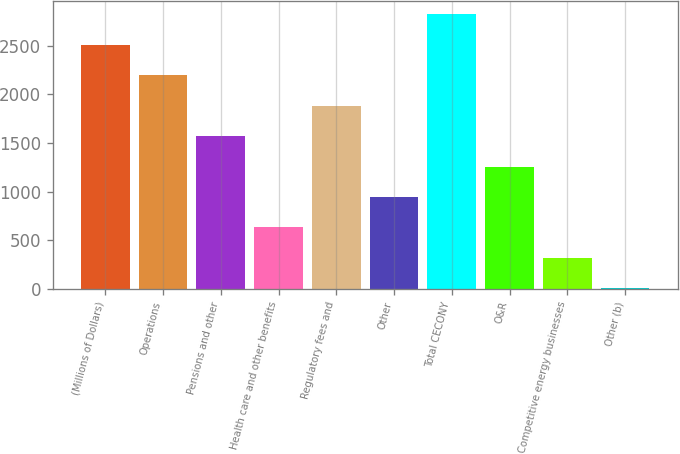Convert chart to OTSL. <chart><loc_0><loc_0><loc_500><loc_500><bar_chart><fcel>(Millions of Dollars)<fcel>Operations<fcel>Pensions and other<fcel>Health care and other benefits<fcel>Regulatory fees and<fcel>Other<fcel>Total CECONY<fcel>O&R<fcel>Competitive energy businesses<fcel>Other (b)<nl><fcel>2510.6<fcel>2197.4<fcel>1571<fcel>631.4<fcel>1884.2<fcel>944.6<fcel>2823.8<fcel>1257.8<fcel>318.2<fcel>5<nl></chart> 